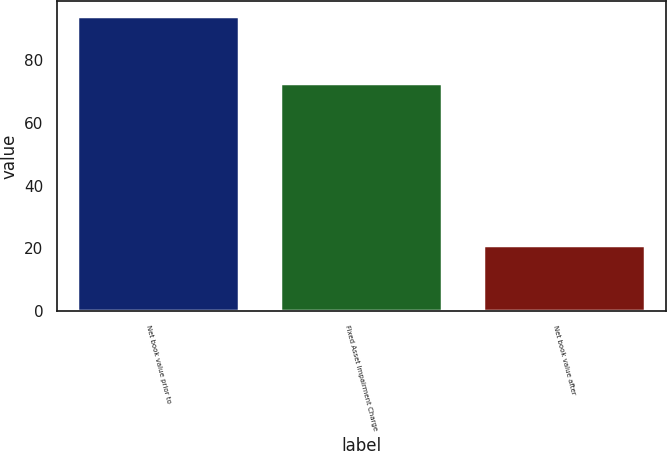Convert chart to OTSL. <chart><loc_0><loc_0><loc_500><loc_500><bar_chart><fcel>Net book value prior to<fcel>Fixed Asset Impairment Charge<fcel>Net book value after<nl><fcel>94.1<fcel>72.9<fcel>21.2<nl></chart> 